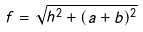<formula> <loc_0><loc_0><loc_500><loc_500>f = \sqrt { h ^ { 2 } + ( a + b ) ^ { 2 } }</formula> 